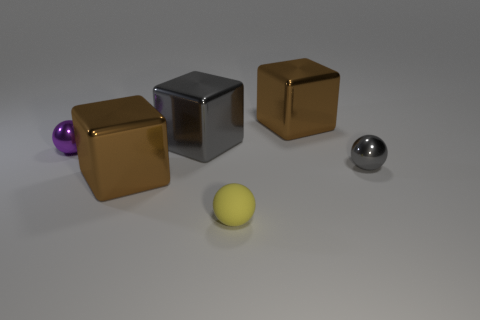Add 4 shiny things. How many objects exist? 10 Add 4 yellow rubber things. How many yellow rubber things are left? 5 Add 1 purple shiny balls. How many purple shiny balls exist? 2 Subtract 0 red balls. How many objects are left? 6 Subtract all small blue metal objects. Subtract all yellow matte things. How many objects are left? 5 